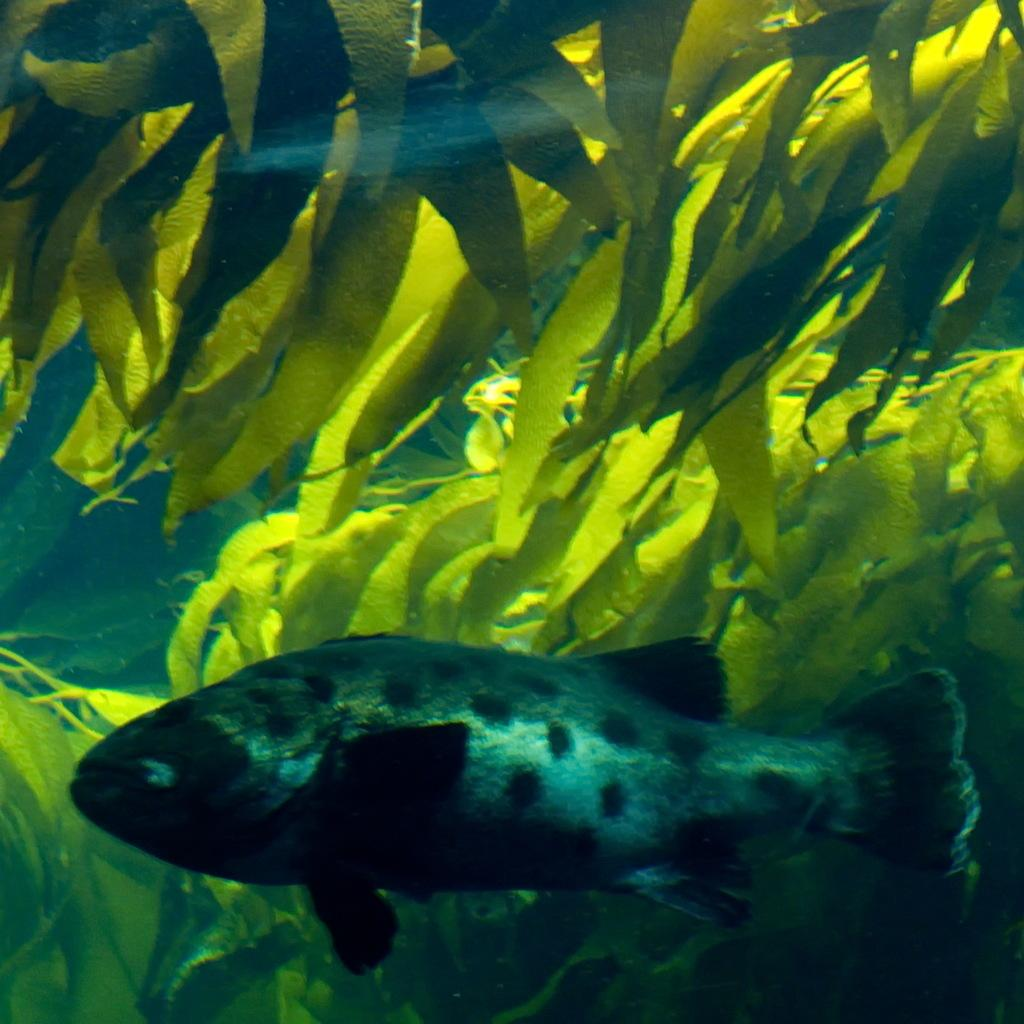What types of living organisms can be seen in the image? There are many plants in the image. Can any aquatic life be observed in the image? Yes, there is a fish in the water in the image. What color is the brain of the fish in the image? There is no brain visible in the image, as it only shows a fish in the water. 